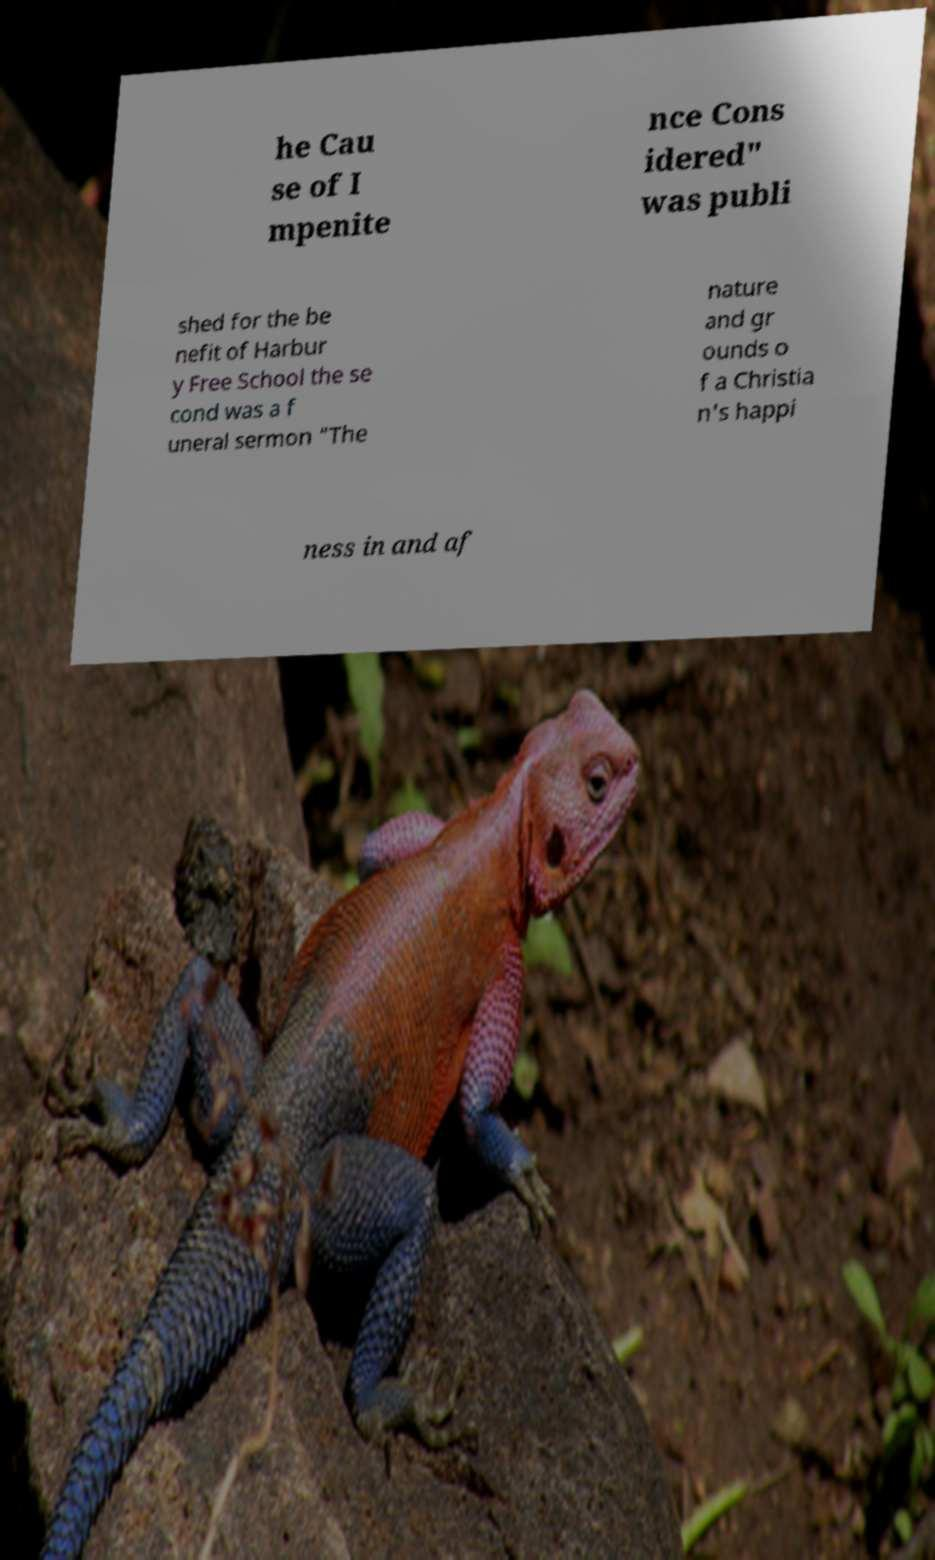For documentation purposes, I need the text within this image transcribed. Could you provide that? he Cau se of I mpenite nce Cons idered" was publi shed for the be nefit of Harbur y Free School the se cond was a f uneral sermon "The nature and gr ounds o f a Christia n's happi ness in and af 